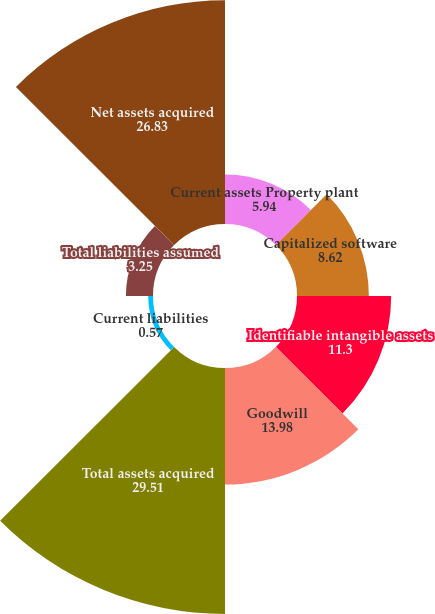<chart> <loc_0><loc_0><loc_500><loc_500><pie_chart><fcel>Current assets Property plant<fcel>Capitalized software<fcel>Identifiable intangible assets<fcel>Goodwill<fcel>Total assets acquired<fcel>Current liabilities<fcel>Total liabilities assumed<fcel>Net assets acquired<nl><fcel>5.94%<fcel>8.62%<fcel>11.3%<fcel>13.98%<fcel>29.51%<fcel>0.57%<fcel>3.25%<fcel>26.83%<nl></chart> 